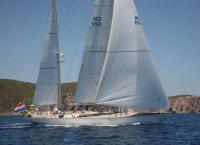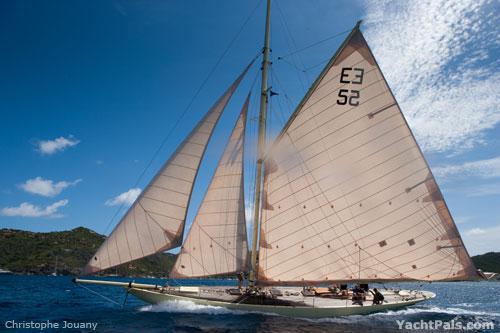The first image is the image on the left, the second image is the image on the right. For the images shown, is this caption "The boat on the right has more than three visible sails unfurled." true? Answer yes or no. No. The first image is the image on the left, the second image is the image on the right. For the images shown, is this caption "All sailboats have at least four sails." true? Answer yes or no. No. 